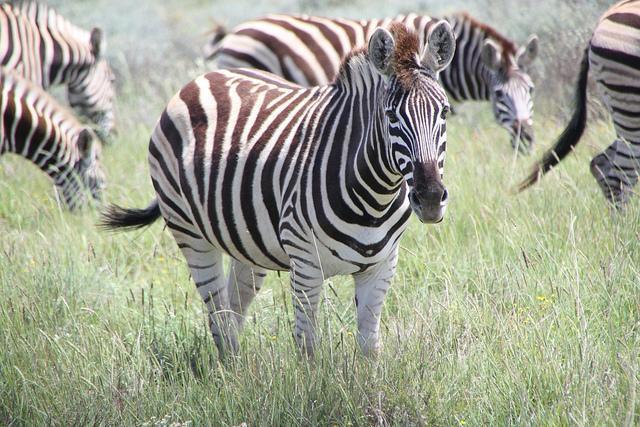How many zebras are there?
Give a very brief answer. 5. How many zebras can you see?
Give a very brief answer. 5. 